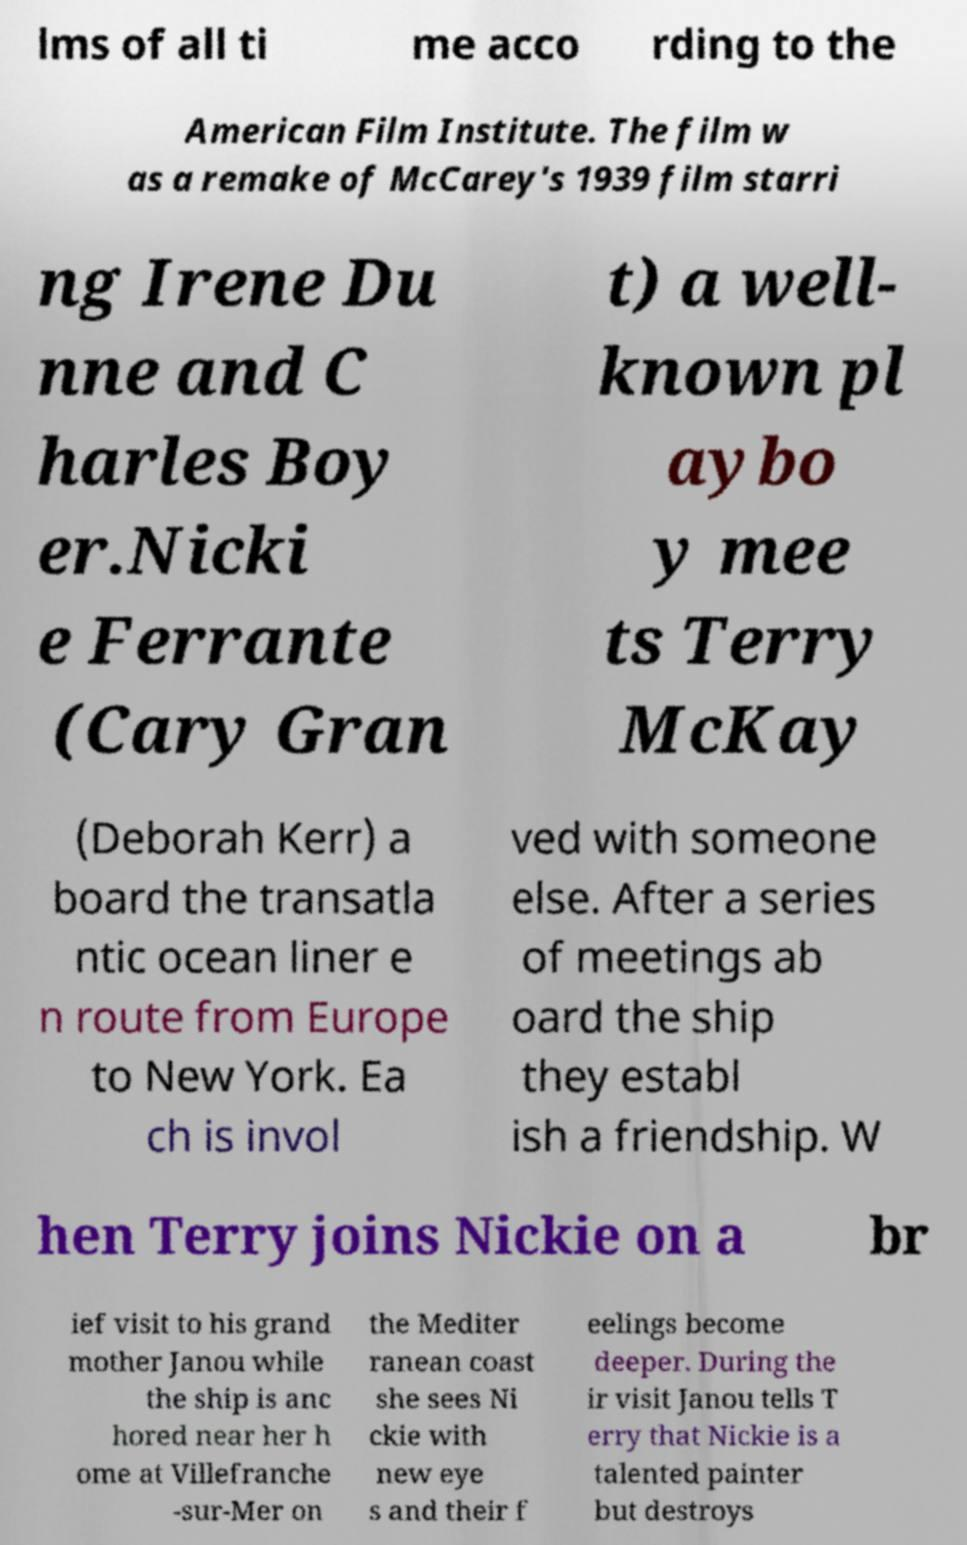Can you read and provide the text displayed in the image?This photo seems to have some interesting text. Can you extract and type it out for me? lms of all ti me acco rding to the American Film Institute. The film w as a remake of McCarey's 1939 film starri ng Irene Du nne and C harles Boy er.Nicki e Ferrante (Cary Gran t) a well- known pl aybo y mee ts Terry McKay (Deborah Kerr) a board the transatla ntic ocean liner e n route from Europe to New York. Ea ch is invol ved with someone else. After a series of meetings ab oard the ship they establ ish a friendship. W hen Terry joins Nickie on a br ief visit to his grand mother Janou while the ship is anc hored near her h ome at Villefranche -sur-Mer on the Mediter ranean coast she sees Ni ckie with new eye s and their f eelings become deeper. During the ir visit Janou tells T erry that Nickie is a talented painter but destroys 